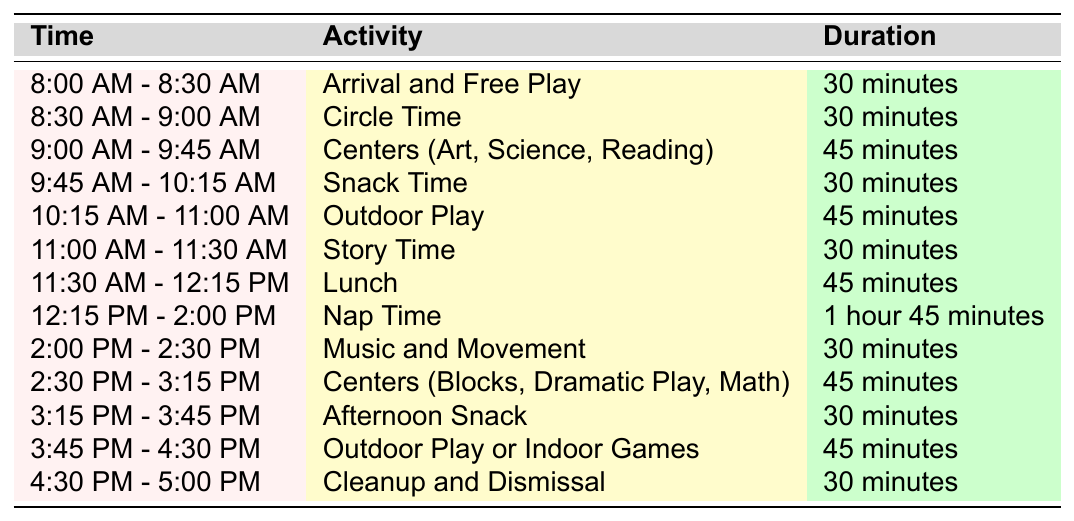What time does Circle Time start? According to the table, Circle Time is scheduled from 8:30 AM to 9:00 AM. Thus, Circle Time starts at 8:30 AM.
Answer: 8:30 AM How long does Nap Time last? The table indicates that Nap Time lasts from 12:15 PM to 2:00 PM. Calculating the duration gives us 1 hour and 45 minutes.
Answer: 1 hour 45 minutes Which activity has the longest duration? By reviewing the activities listed, Nap Time has the longest duration of 1 hour and 45 minutes, compared to other activities.
Answer: Nap Time How much time is allocated for Snack Time? The table specifies that Snack Time lasts for 30 minutes.
Answer: 30 minutes What is the total duration of outdoor play activities? There are two outdoor activities: Outdoor Play from 10:15 AM to 11:00 AM (45 minutes) and Outdoor Play or Indoor Games from 3:45 PM to 4:30 PM (45 minutes). Adding these, 45 + 45 = 90 minutes total.
Answer: 90 minutes Does Story Time occur before or after Lunch? The table shows Story Time occurs from 11:00 AM to 11:30 AM, while Lunch is from 11:30 AM to 12:15 PM. Therefore, Story Time occurs before Lunch.
Answer: Before What activities are scheduled right after Snack Time? After Snack Time (which ends at 10:15 AM), the next activity listed is Outdoor Play, scheduled from 10:15 AM to 11:00 AM.
Answer: Outdoor Play Is the duration of Cleanup and Dismissal the same as that for Circle Time? Circle Time lasts for 30 minutes, and Cleanup and Dismissal also lasts for 30 minutes. Therefore, their durations are the same.
Answer: Yes What is the total duration of activities between 8:00 AM and 10:15 AM? The activities include Arrival and Free Play (30 minutes), Circle Time (30 minutes), Centers (45 minutes), and Snack Time (30 minutes). Adding these gives: 30 + 30 + 45 + 30 = 135 minutes.
Answer: 135 minutes How many activities are scheduled for 45 minutes? The table shows three activities that last 45 minutes: Centers (Art, Science, Reading), Outdoor Play, and Centers (Blocks, Dramatic Play, Math). Therefore, there are three 45-minute activities.
Answer: 3 activities 